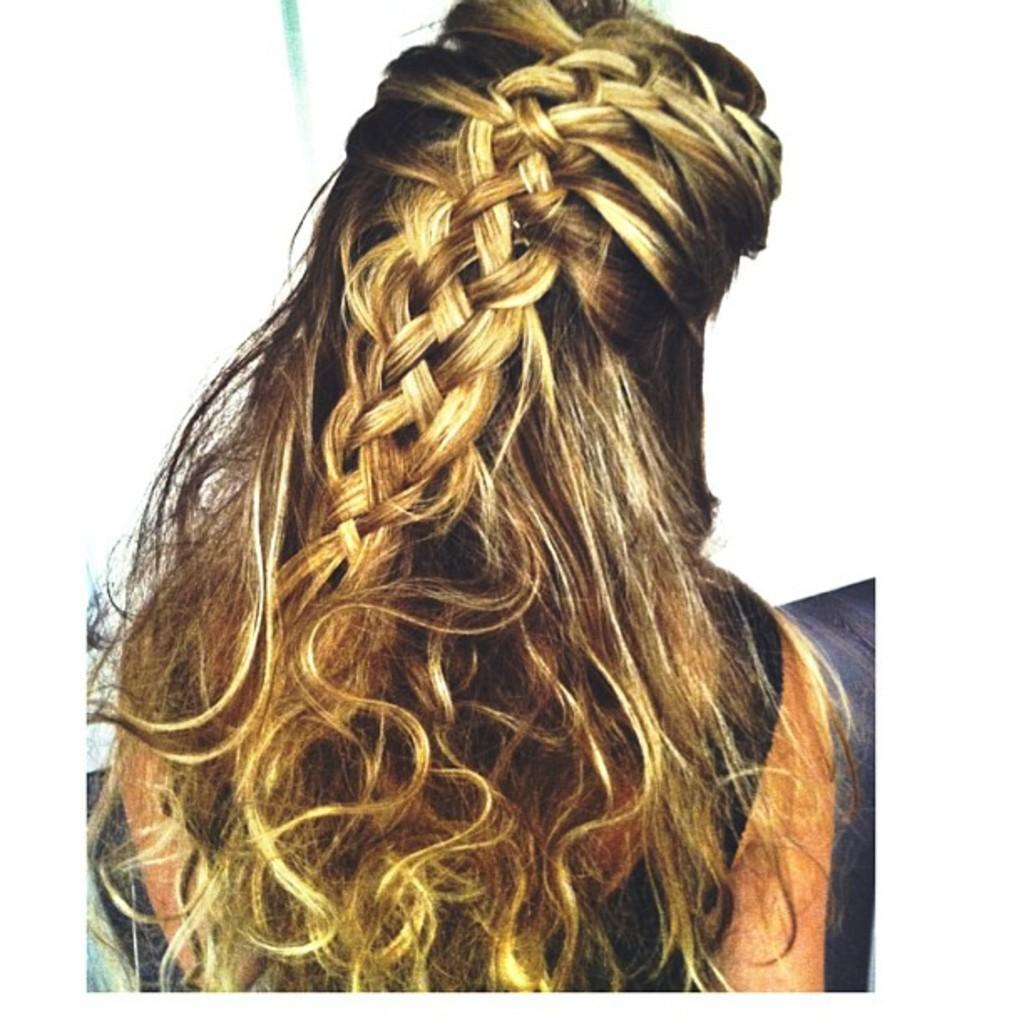Who is the main subject in the image? There is a woman in the center of the image. What type of creature is performing magic tricks with a dog in the image? There is no creature or dog present in the image; it only features a woman. 